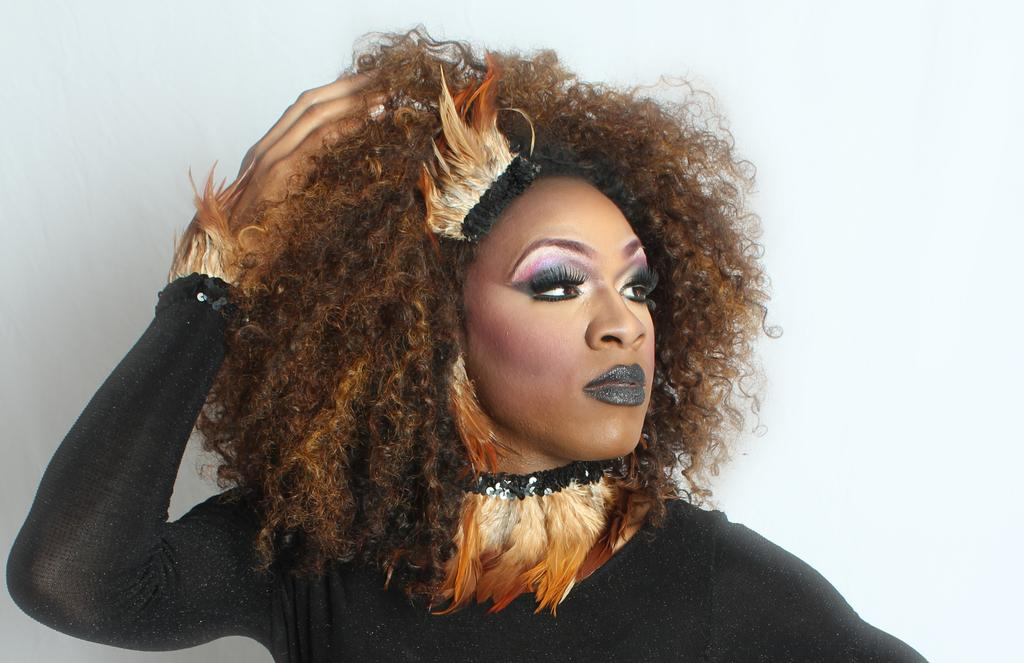Who is the main subject in the image? There is a woman in the image. What is the woman wearing? The woman is wearing a black dress. Where is the woman located in the image? The woman is standing near a wall. What type of cloth is the woman using to bite in the image? There is no cloth or biting action present in the image; the woman is simply standing near a wall. 